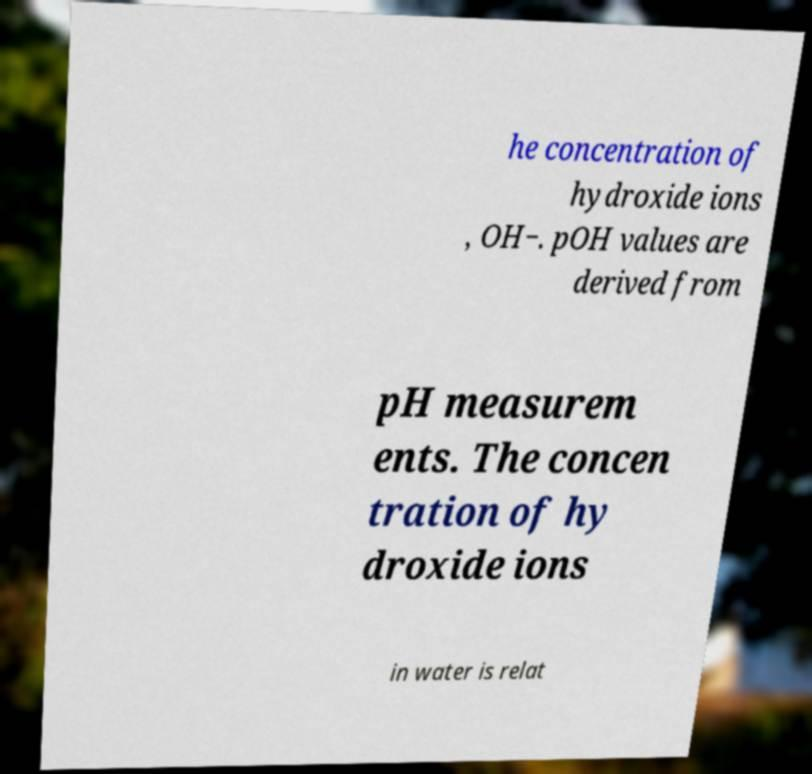For documentation purposes, I need the text within this image transcribed. Could you provide that? he concentration of hydroxide ions , OH−. pOH values are derived from pH measurem ents. The concen tration of hy droxide ions in water is relat 